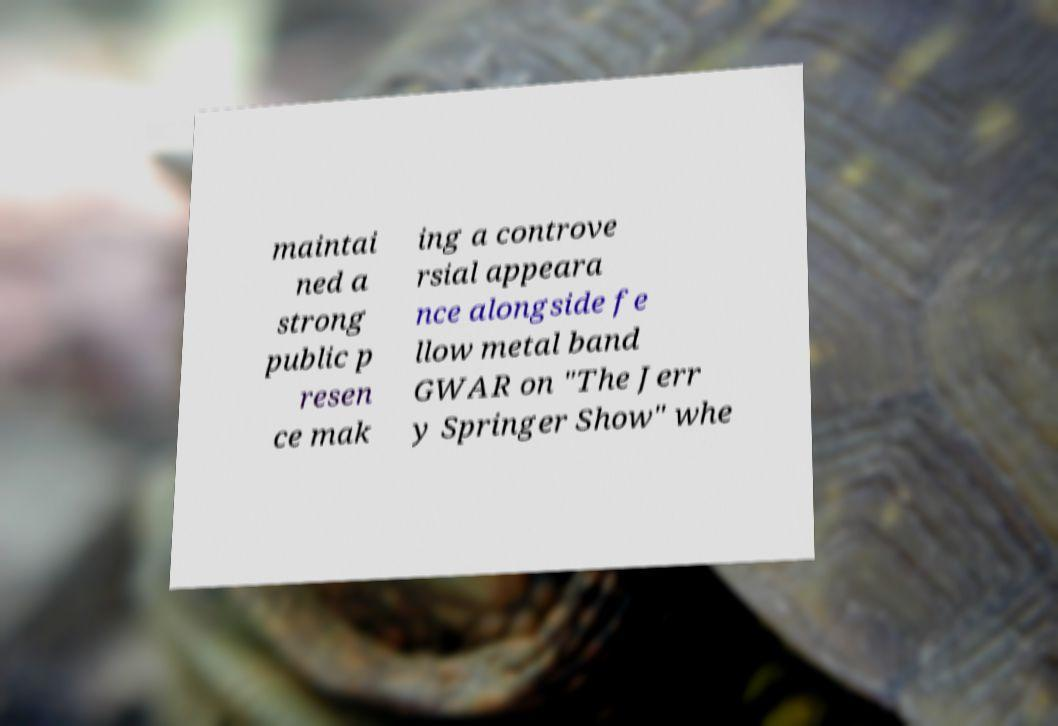Can you accurately transcribe the text from the provided image for me? maintai ned a strong public p resen ce mak ing a controve rsial appeara nce alongside fe llow metal band GWAR on "The Jerr y Springer Show" whe 